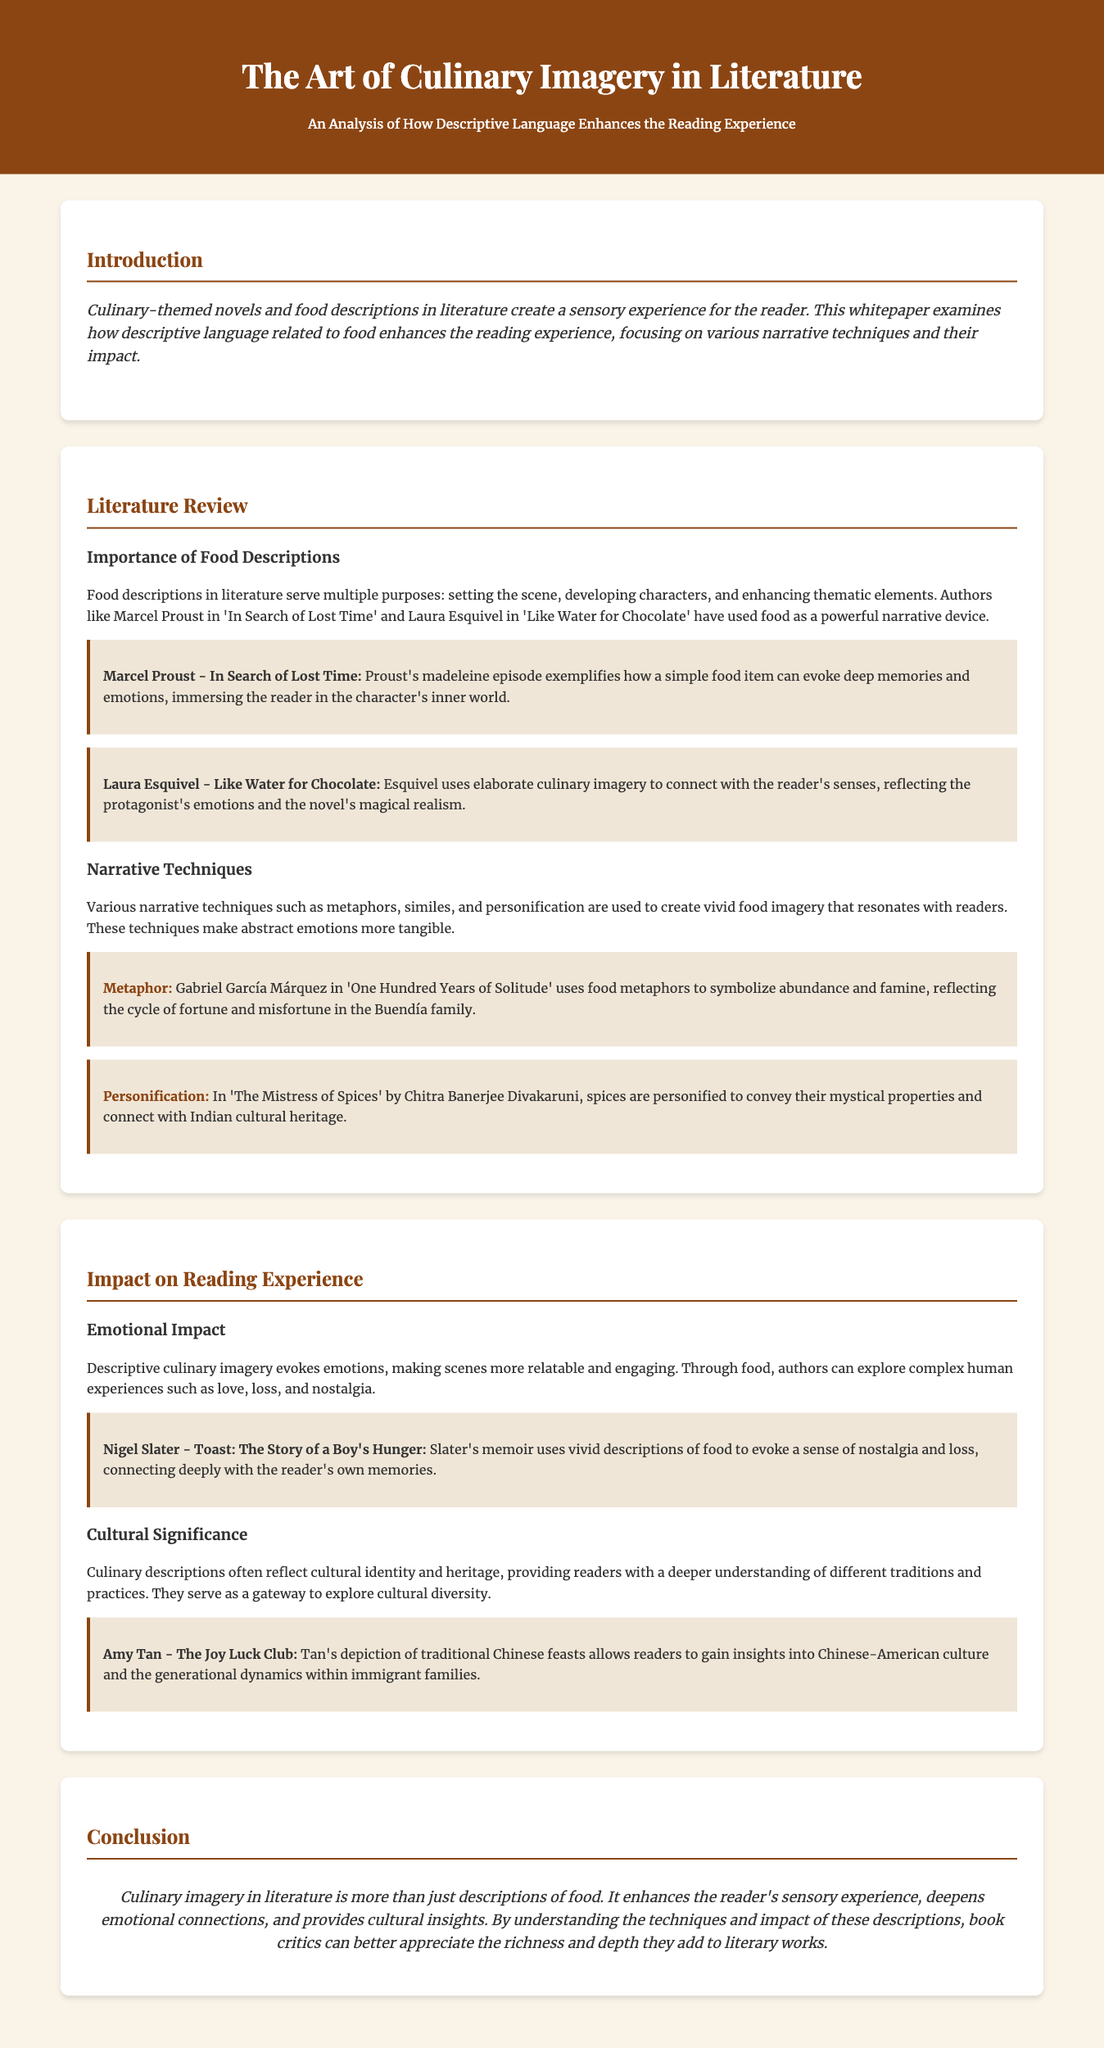What is the main focus of the whitepaper? The whitepaper examines how descriptive language related to food enhances the reading experience, focusing on various narrative techniques and their impact.
Answer: Descriptive language related to food Who are the authors mentioned in the literature review? The authors discussed include Marcel Proust, Laura Esquivel, Gabriel García Márquez, and Chitra Banerjee Divakaruni.
Answer: Marcel Proust, Laura Esquivel, Gabriel García Márquez, Chitra Banerjee Divakaruni What culinary technique does Gabriel García Márquez use in his work? Márquez uses food metaphors to symbolize abundance and famine, reflecting the cycle of fortune and misfortune in the Buendía family.
Answer: Food metaphors Which memoir evokes a sense of nostalgia through food descriptions? Nigel Slater's memoir "Toast: The Story of a Boy's Hunger" uses vivid descriptions of food to evoke nostalgia and loss.
Answer: Toast: The Story of a Boy's Hunger What cultural significance do culinary descriptions provide in literature? Culinary descriptions reflect cultural identity and heritage, providing readers with a deeper understanding of different traditions and practices.
Answer: Cultural identity and heritage What is the concluding statement of the whitepaper? The conclusion states that culinary imagery in literature enhances the reader's sensory experience, deepens emotional connections, and provides cultural insights.
Answer: Enhances the reader's sensory experience What are two narrative techniques used to create food imagery? Metaphors and personification are two narrative techniques mentioned in the document.
Answer: Metaphors and personification 